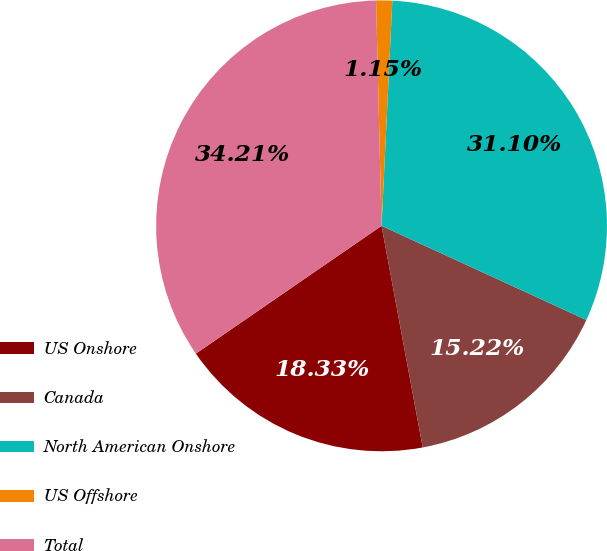Convert chart. <chart><loc_0><loc_0><loc_500><loc_500><pie_chart><fcel>US Onshore<fcel>Canada<fcel>North American Onshore<fcel>US Offshore<fcel>Total<nl><fcel>18.33%<fcel>15.22%<fcel>31.1%<fcel>1.15%<fcel>34.21%<nl></chart> 